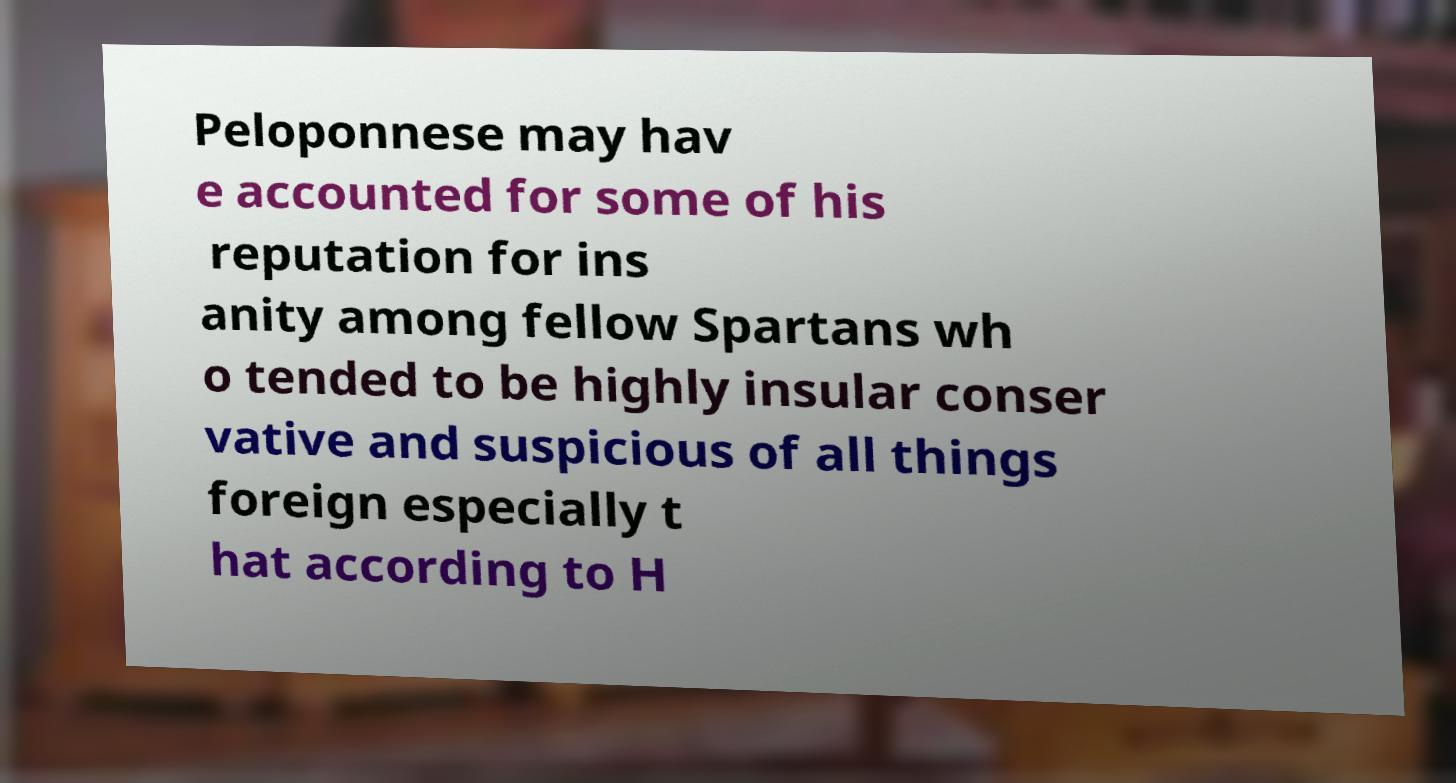Could you extract and type out the text from this image? Peloponnese may hav e accounted for some of his reputation for ins anity among fellow Spartans wh o tended to be highly insular conser vative and suspicious of all things foreign especially t hat according to H 